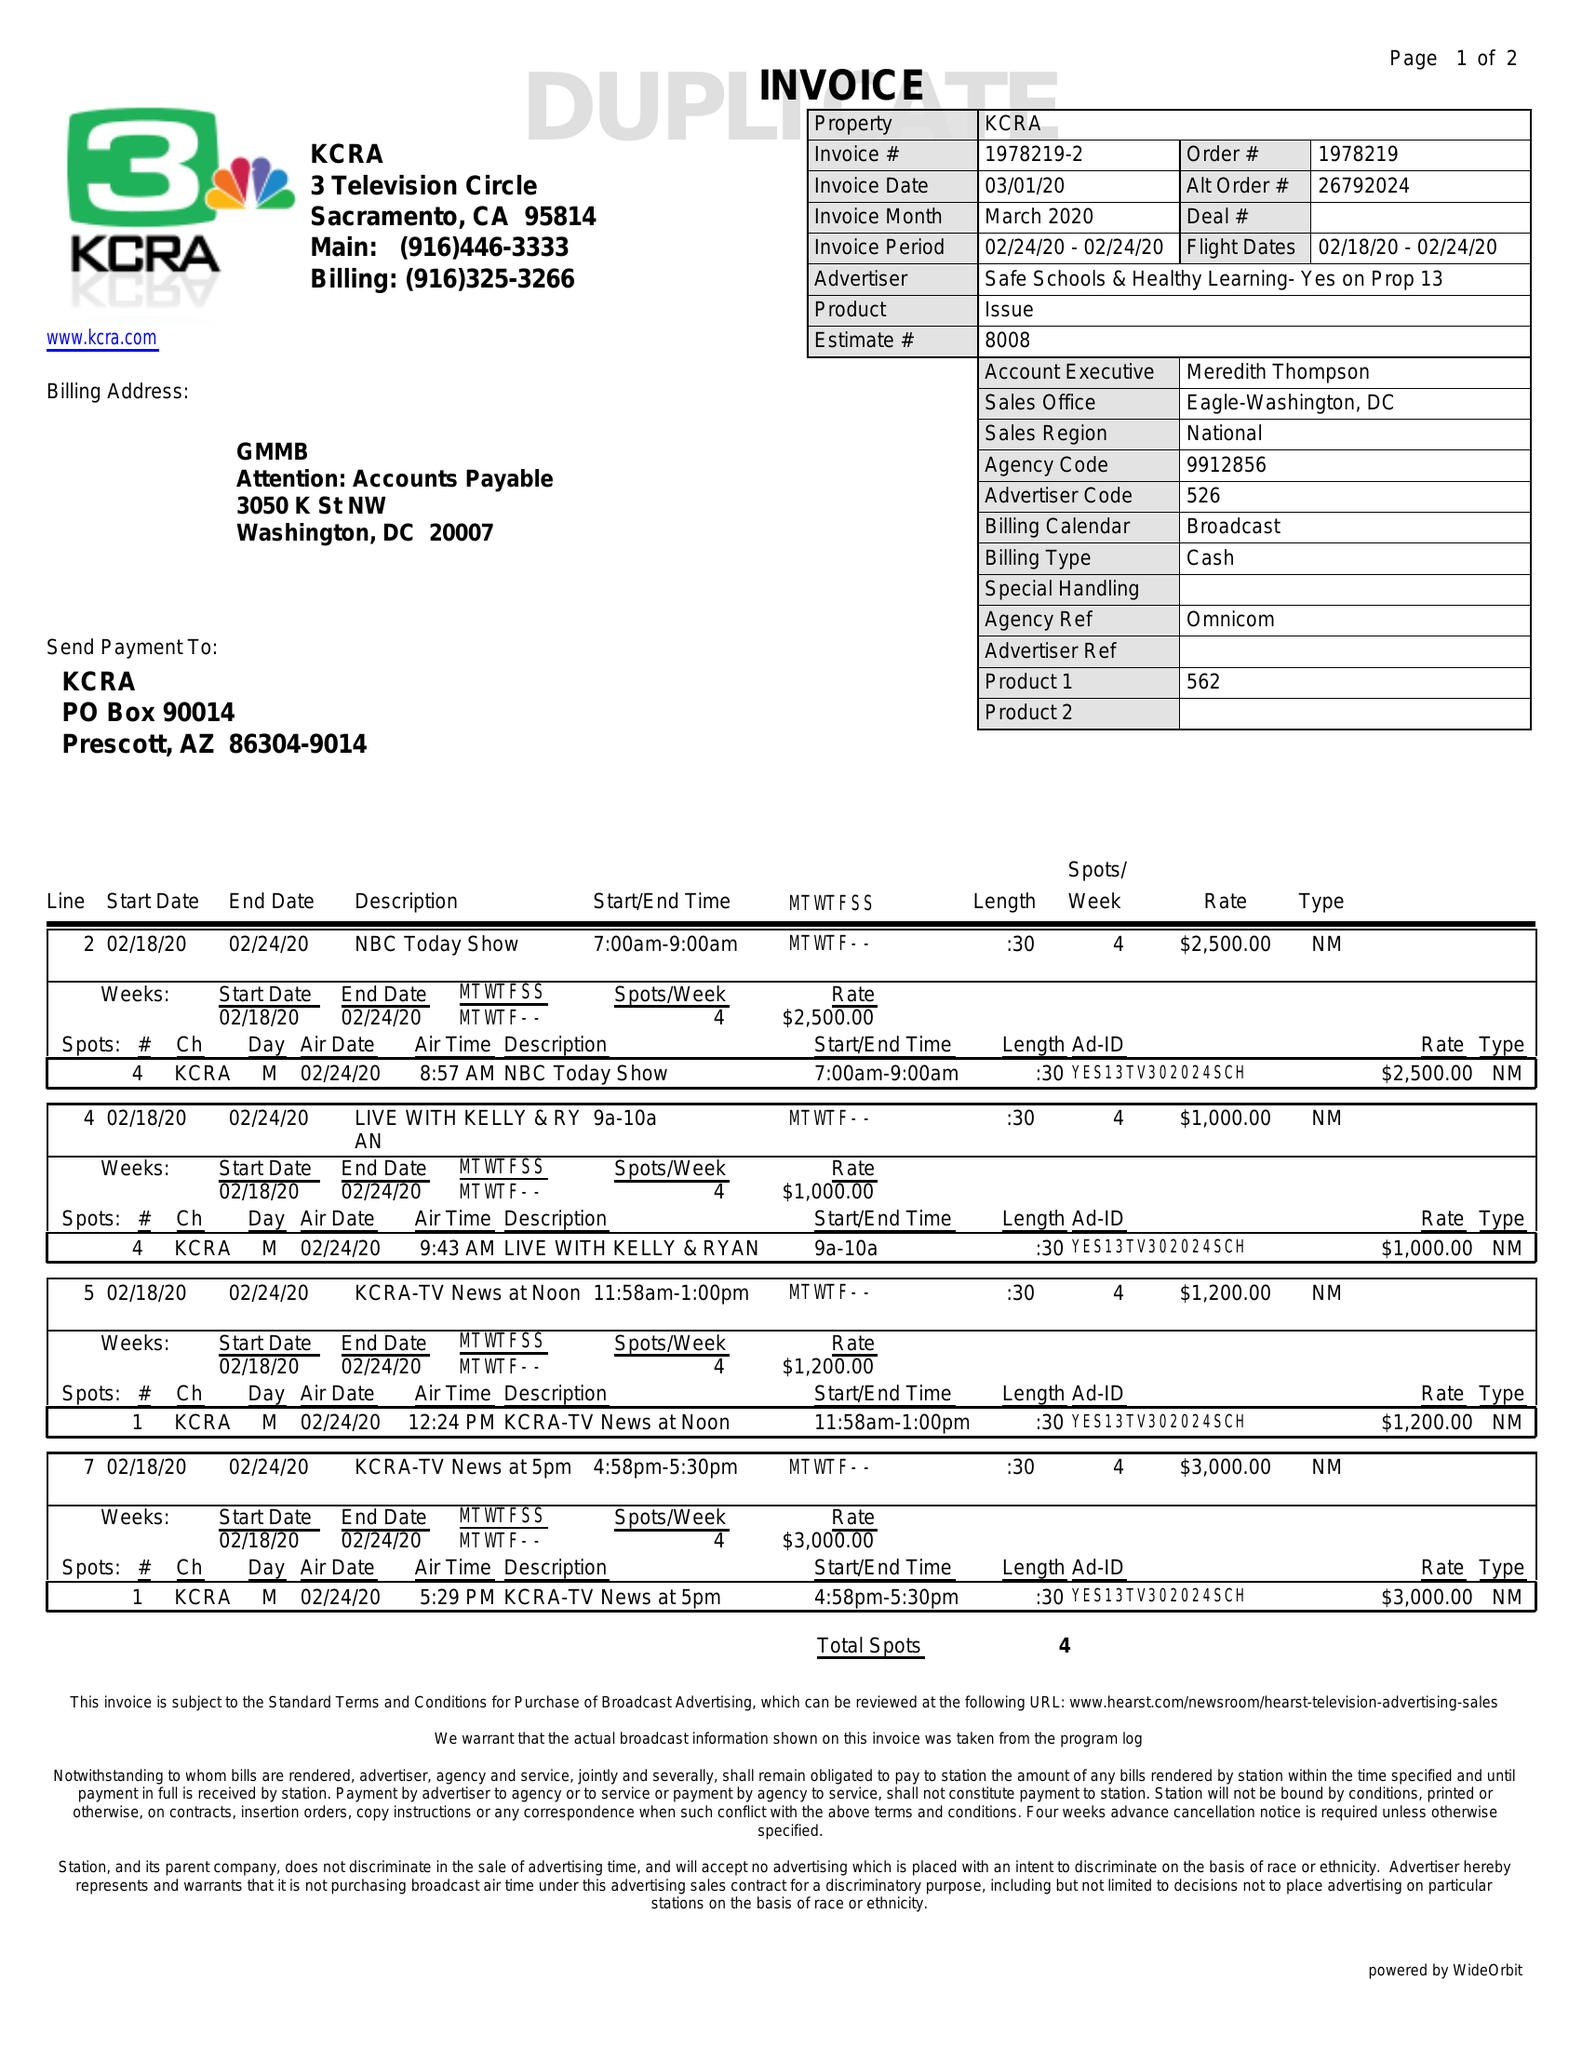What is the value for the gross_amount?
Answer the question using a single word or phrase. 7700.00 